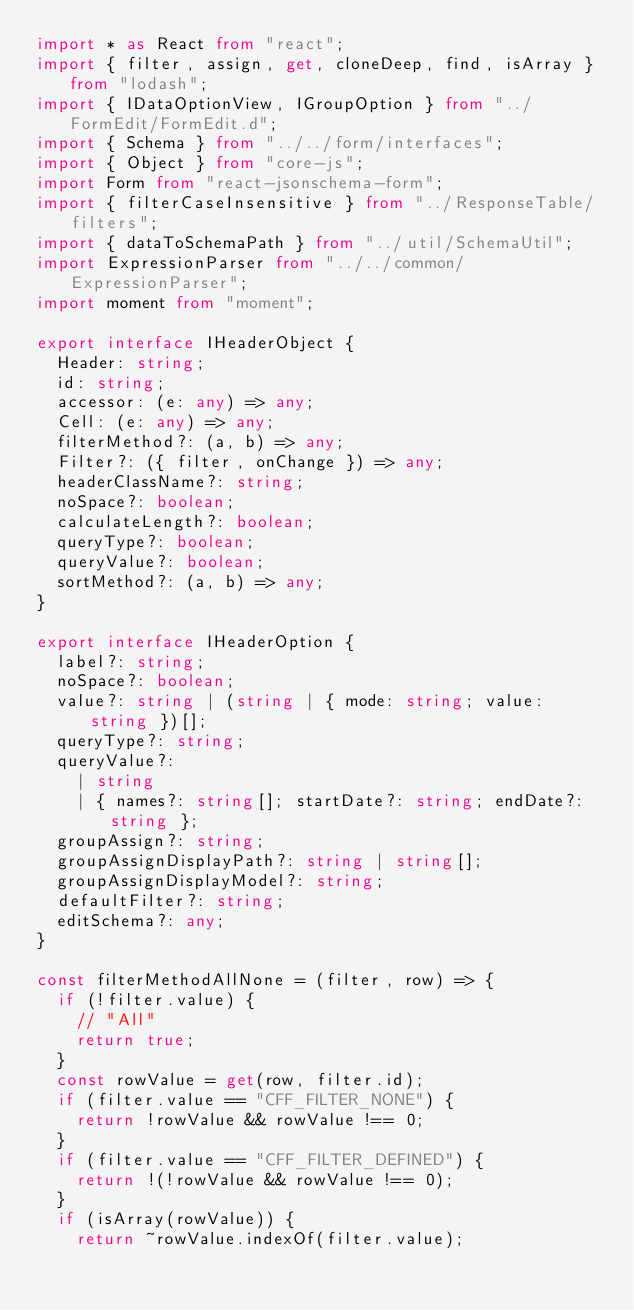Convert code to text. <code><loc_0><loc_0><loc_500><loc_500><_TypeScript_>import * as React from "react";
import { filter, assign, get, cloneDeep, find, isArray } from "lodash";
import { IDataOptionView, IGroupOption } from "../FormEdit/FormEdit.d";
import { Schema } from "../../form/interfaces";
import { Object } from "core-js";
import Form from "react-jsonschema-form";
import { filterCaseInsensitive } from "../ResponseTable/filters";
import { dataToSchemaPath } from "../util/SchemaUtil";
import ExpressionParser from "../../common/ExpressionParser";
import moment from "moment";

export interface IHeaderObject {
  Header: string;
  id: string;
  accessor: (e: any) => any;
  Cell: (e: any) => any;
  filterMethod?: (a, b) => any;
  Filter?: ({ filter, onChange }) => any;
  headerClassName?: string;
  noSpace?: boolean;
  calculateLength?: boolean;
  queryType?: boolean;
  queryValue?: boolean;
  sortMethod?: (a, b) => any;
}

export interface IHeaderOption {
  label?: string;
  noSpace?: boolean;
  value?: string | (string | { mode: string; value: string })[];
  queryType?: string;
  queryValue?:
    | string
    | { names?: string[]; startDate?: string; endDate?: string };
  groupAssign?: string;
  groupAssignDisplayPath?: string | string[];
  groupAssignDisplayModel?: string;
  defaultFilter?: string;
  editSchema?: any;
}

const filterMethodAllNone = (filter, row) => {
  if (!filter.value) {
    // "All"
    return true;
  }
  const rowValue = get(row, filter.id);
  if (filter.value == "CFF_FILTER_NONE") {
    return !rowValue && rowValue !== 0;
  }
  if (filter.value == "CFF_FILTER_DEFINED") {
    return !(!rowValue && rowValue !== 0);
  }
  if (isArray(rowValue)) {
    return ~rowValue.indexOf(filter.value);</code> 